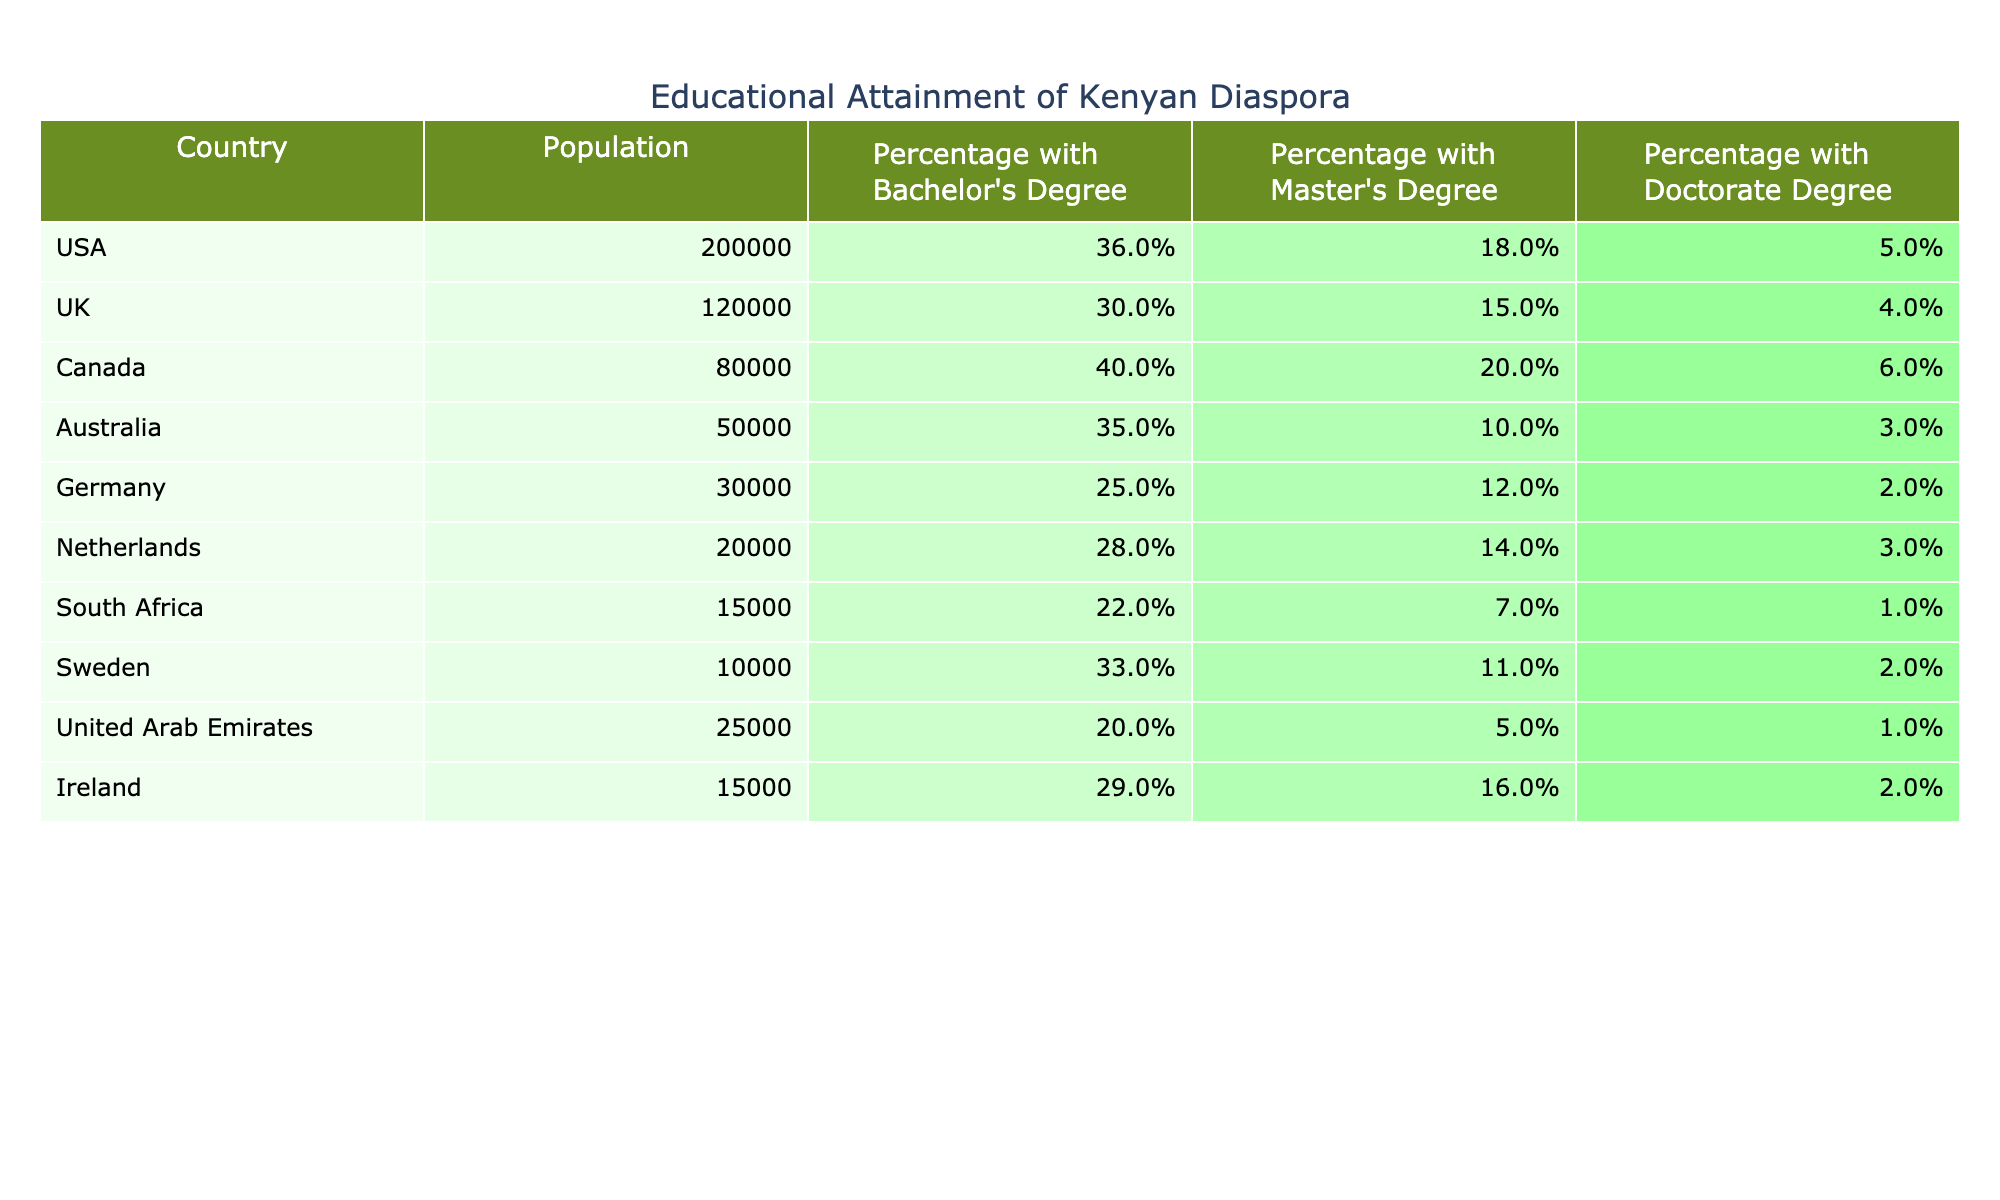What country has the highest percentage of its diaspora population with a Bachelor's Degree? The table shows the percentage of the population with a Bachelor's Degree by country. By reviewing the values, Canada has the highest percentage with 40%.
Answer: Canada Which host country has the lowest percentage of doctoral degree holders among the Kenyan diaspora? The table lists the percentage of population with a Doctorate Degree for each country. South Africa has the lowest percentage at 1%.
Answer: South Africa What is the average percentage of Kenyan diaspora with a Master's Degree across all listed countries? To find the average, I will sum the percentages of Master's Degrees and divide by the number of countries: (18 + 15 + 20 + 10 + 12 + 14 + 7 + 11 + 5 + 16) = 118, then divide by 10, which gives 11.8%.
Answer: 11.8% Is the percentage of Kenyan diaspora with a Bachelor's Degree in the UAE more than or equal to that in Germany? The table shows the UAE percentage as 20% and Germany's as 25%. Since 20% is less than 25%, the statement is false.
Answer: False How does the percentage of Kenyans with Doctorate Degrees in Canada compare to that in the UK? The percentage for Canada is 6% and for the UK is 4%. Thus, 6% is greater than 4%, showing that Canada has a higher percentage.
Answer: Canada has a higher percentage 